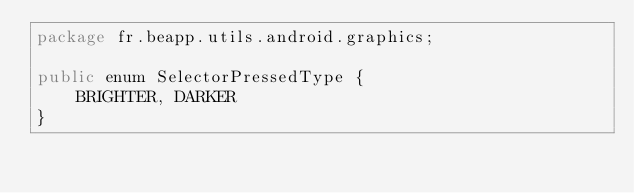<code> <loc_0><loc_0><loc_500><loc_500><_Java_>package fr.beapp.utils.android.graphics;

public enum SelectorPressedType {
	BRIGHTER, DARKER
}
</code> 